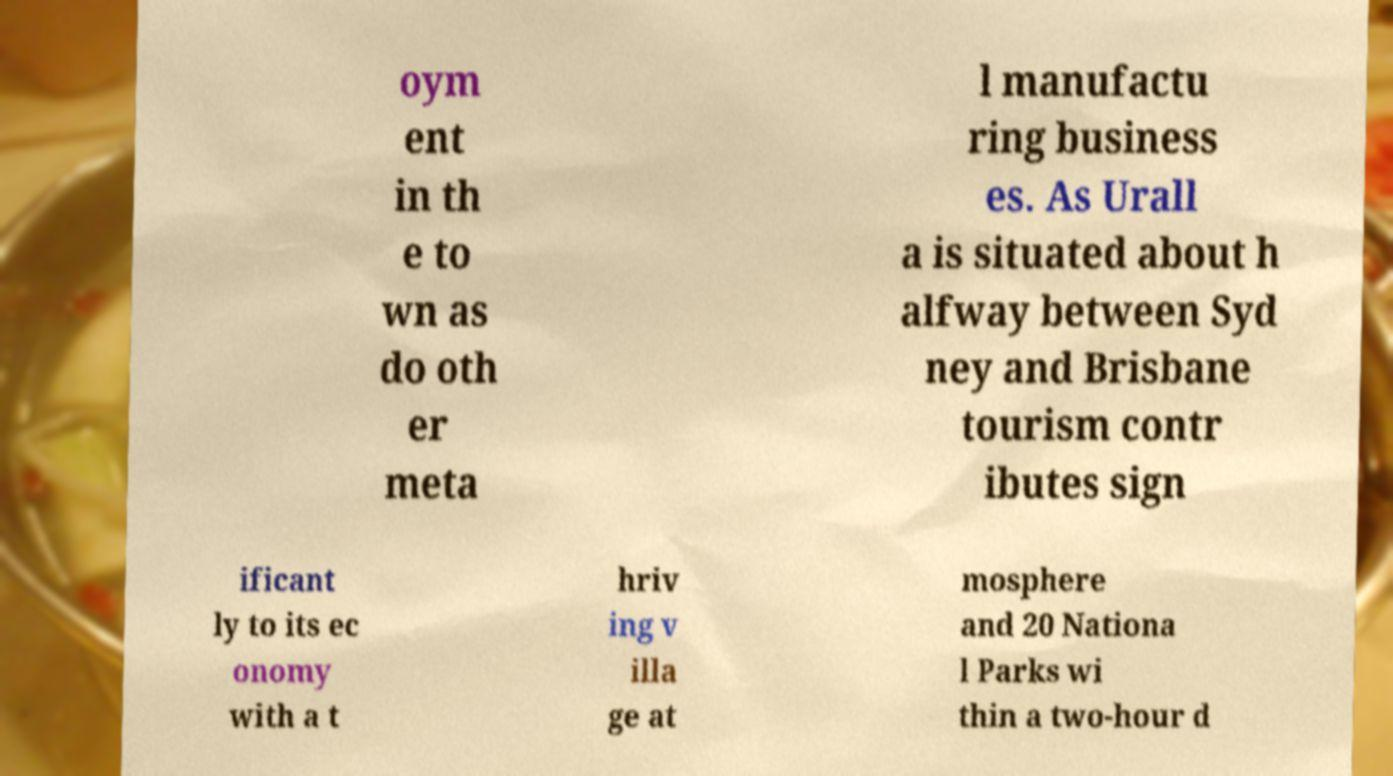There's text embedded in this image that I need extracted. Can you transcribe it verbatim? oym ent in th e to wn as do oth er meta l manufactu ring business es. As Urall a is situated about h alfway between Syd ney and Brisbane tourism contr ibutes sign ificant ly to its ec onomy with a t hriv ing v illa ge at mosphere and 20 Nationa l Parks wi thin a two-hour d 